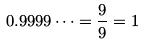Convert formula to latex. <formula><loc_0><loc_0><loc_500><loc_500>0 . 9 9 9 9 \dots = \frac { 9 } { 9 } = 1</formula> 